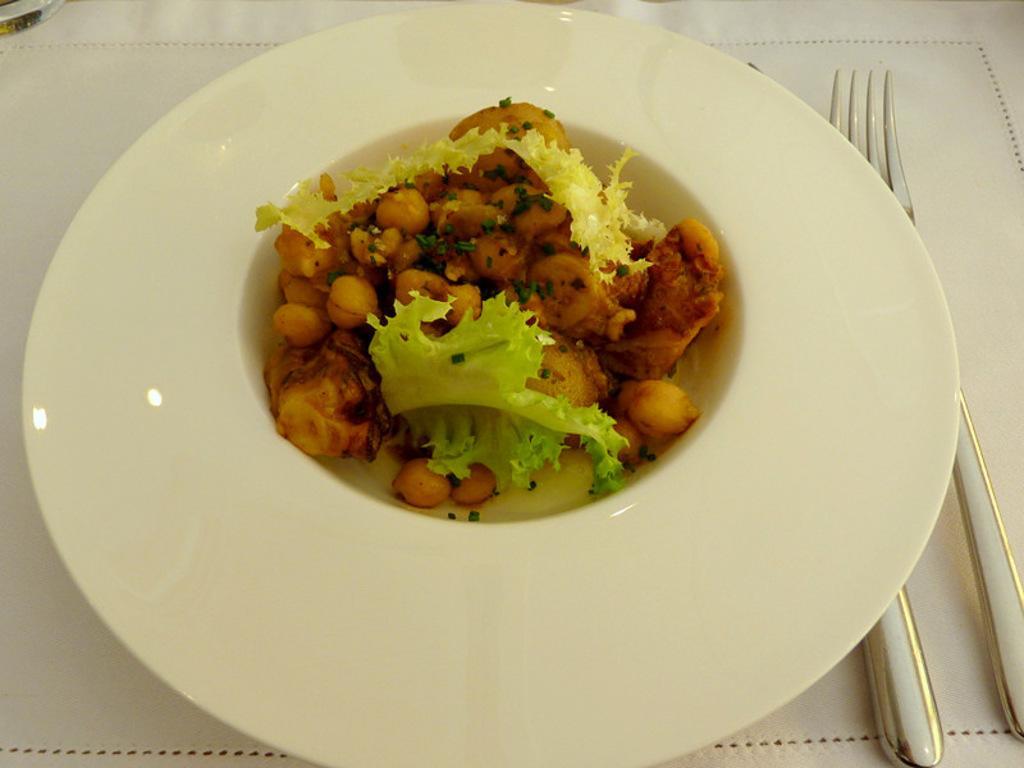Can you describe this image briefly? This image consist of food which is on the plate in the center. On the right side of the plate there are folks. 